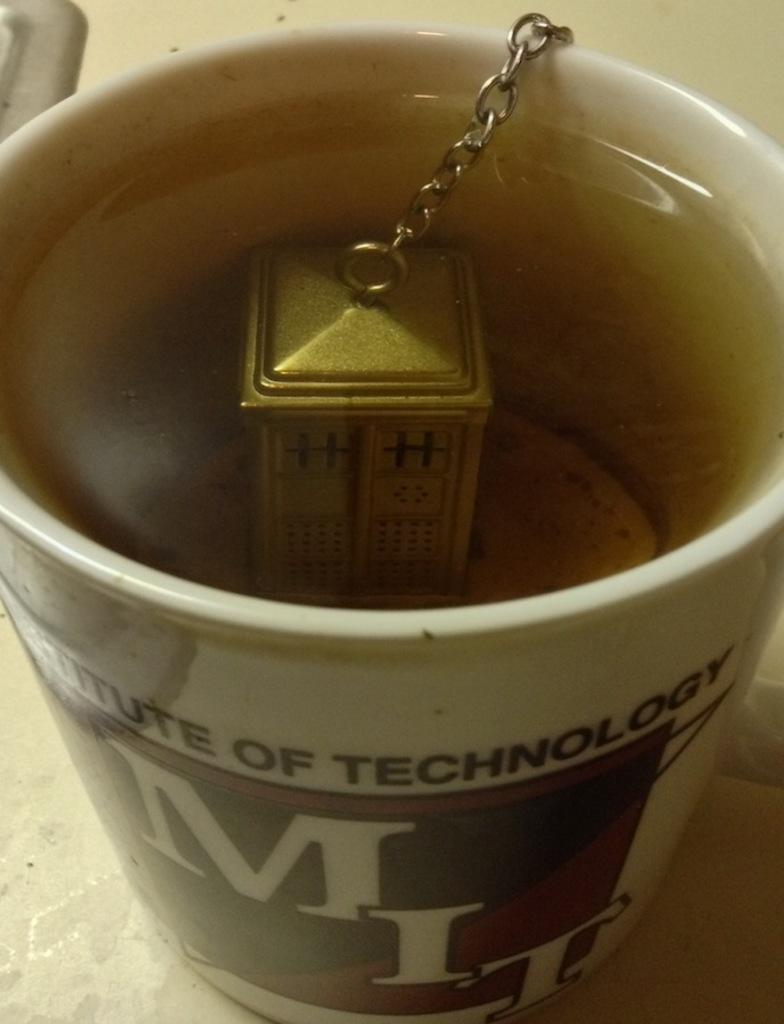<image>
Share a concise interpretation of the image provided. Someone is making tea in an MIT mug with a Tardis tea diffuser. 